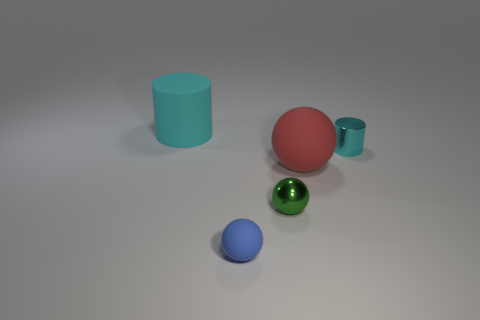Do the green object and the tiny blue matte thing to the left of the red rubber ball have the same shape?
Your response must be concise. Yes. What number of other objects are there of the same shape as the tiny green shiny thing?
Your answer should be very brief. 2. What number of things are either yellow metal cylinders or big balls?
Your answer should be very brief. 1. Is the color of the metal cylinder the same as the large matte cylinder?
Ensure brevity in your answer.  Yes. There is a cyan thing behind the small cyan metallic cylinder that is to the right of the big cyan rubber thing; what is its shape?
Make the answer very short. Cylinder. Are there fewer cyan metal objects than tiny red metallic cylinders?
Your answer should be compact. No. How big is the thing that is on the left side of the green metallic ball and in front of the big rubber sphere?
Keep it short and to the point. Small. Is the cyan matte cylinder the same size as the red rubber thing?
Give a very brief answer. Yes. Does the large matte object left of the big sphere have the same color as the small shiny cylinder?
Provide a short and direct response. Yes. There is a big red ball; how many blue objects are to the right of it?
Make the answer very short. 0. 